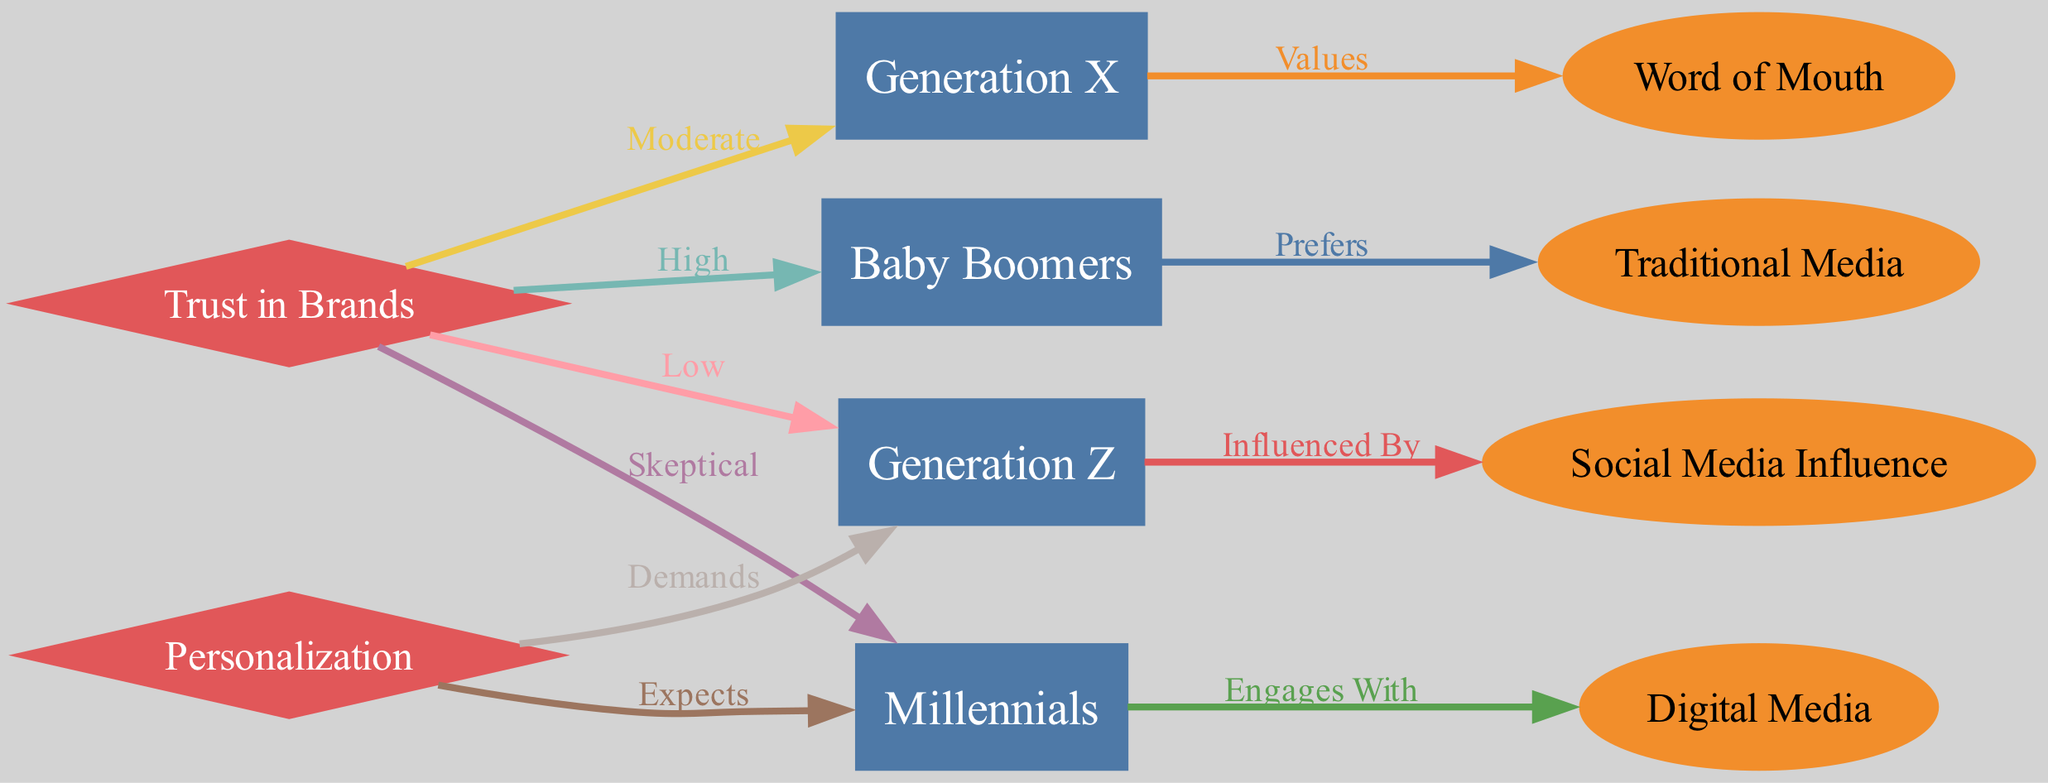What is the preferred media type for Baby Boomers? The diagram directly indicates that Baby Boomers prefer Traditional Media, as shown by the edge connecting "BabyBoomers" to "TraditionalMedia" with the label "Prefers."
Answer: Traditional Media Which generation values Word of Mouth? The diagram clearly states that Generation X values Word of Mouth, evidenced by the edge from "GenerationX" to "WordOfMouth" with the label "Values."
Answer: Generation X How do Millennials engage with media? According to the diagram, Millennials engage with Digital Media, as depicted in the connection from "Millennials" to "DigitalMedia" with the label "Engages With."
Answer: Digital Media What is the level of trust in brands for Generation Z? The diagram specifies that Generation Z has a low level of trust in brands, illustrated by the edge from "TrustInBrands" to "GenZ" with the label "Low."
Answer: Low What do Millennials expect regarding marketing? The diagram shows that Millennials expect Personalization in marketing, as indicated by the edge from "Personalization" to "Millennials" marked with "Expects."
Answer: Personalization How does trust in brands vary among generations? Exploring the edges leading from "TrustInBrands," it is clear that Baby Boomers have a high trust, Generation X has a moderate trust, Millennials are skeptical, and Generation Z has low trust. This indicates a declining trend in trust from Baby Boomers to Generation Z.
Answer: High, Moderate, Skeptical, Low Which generation demands personalization? The diagram illustrates that Generation Z demands Personalization, as seen from the edge connecting "Personalization" to "GenZ" with the label "Demands."
Answer: Generation Z How many nodes represent generations in the diagram? The diagram includes four nodes for generations: Baby Boomers, Generation X, Millennials, and Generation Z. Counting these nodes gives a total of four.
Answer: 4 What is the influence of Social Media on Generation Z? The diagram indicates that Generation Z is influenced by Social Media Influence, as depicted by the edge from "GenZ" to "SocialMediaInfluence" with the label "Influenced By."
Answer: Social Media Influence Which generation is skeptical about trust in brands? The diagram shows that Millennials are skeptical about trust in brands, which is illustrated by the connection from "TrustInBrands" to "Millennials" labeled as "Skeptical."
Answer: Millennials 